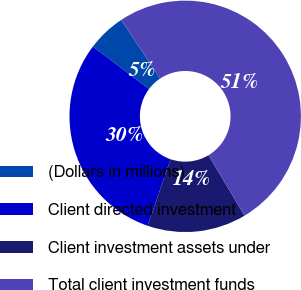Convert chart to OTSL. <chart><loc_0><loc_0><loc_500><loc_500><pie_chart><fcel>(Dollars in millions)<fcel>Client directed investment<fcel>Client investment assets under<fcel>Total client investment funds<nl><fcel>5.37%<fcel>30.04%<fcel>13.83%<fcel>50.76%<nl></chart> 